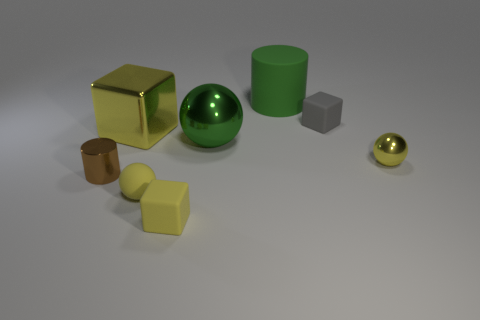There is a big rubber cylinder to the right of the big yellow shiny cube; is it the same color as the shiny sphere to the left of the big green matte cylinder?
Offer a very short reply. Yes. What color is the cylinder that is the same material as the big cube?
Keep it short and to the point. Brown. Are there more large cylinders than tiny blue things?
Keep it short and to the point. Yes. Are any blue matte blocks visible?
Your answer should be very brief. No. What is the shape of the large thing that is left of the ball that is in front of the tiny shiny cylinder?
Offer a terse response. Cube. What number of things are tiny red shiny cylinders or shiny things in front of the big yellow thing?
Keep it short and to the point. 3. What color is the large shiny thing that is on the left side of the small yellow thing that is to the left of the yellow rubber block on the left side of the large metal ball?
Your answer should be compact. Yellow. What material is the green thing that is the same shape as the brown thing?
Provide a succinct answer. Rubber. The large cube has what color?
Keep it short and to the point. Yellow. Is the metallic cylinder the same color as the tiny shiny ball?
Offer a very short reply. No. 